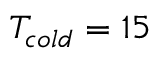<formula> <loc_0><loc_0><loc_500><loc_500>T _ { c o l d } = 1 5</formula> 